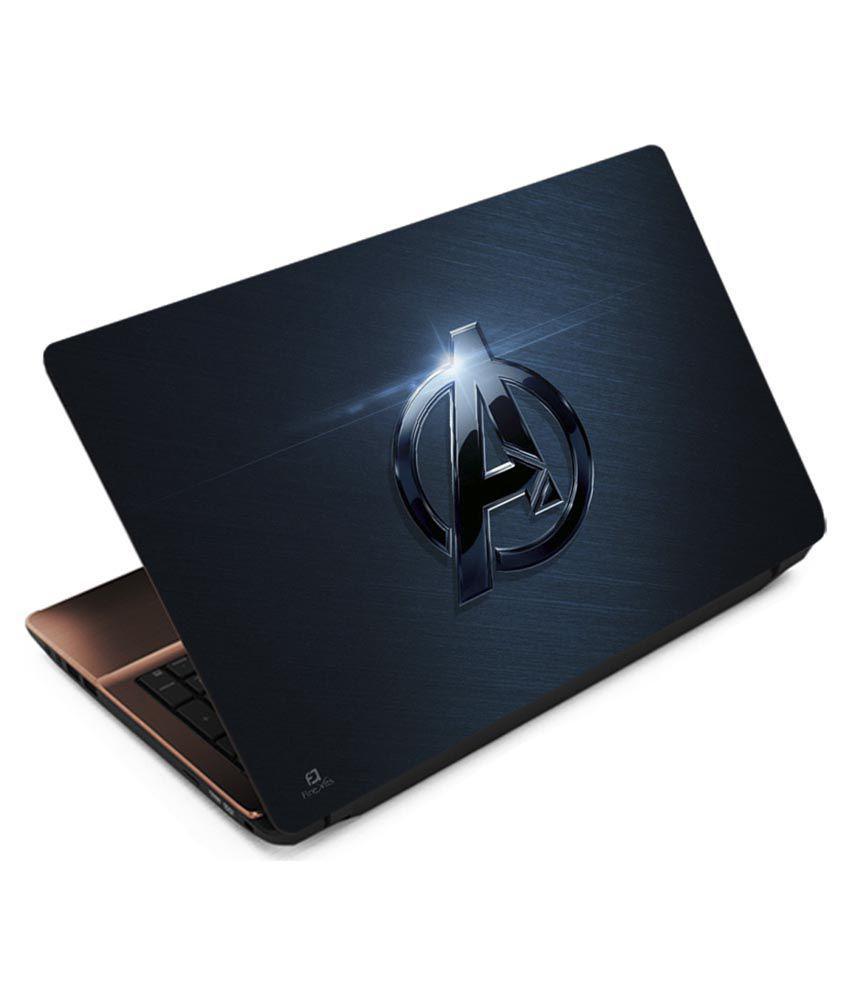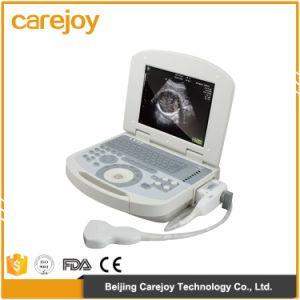The first image is the image on the left, the second image is the image on the right. For the images displayed, is the sentence "In the left image, there's a laptop by itself." factually correct? Answer yes or no. Yes. The first image is the image on the left, the second image is the image on the right. For the images displayed, is the sentence "There is one cord visible." factually correct? Answer yes or no. Yes. 